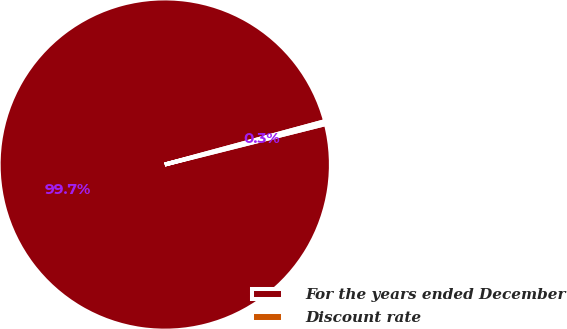<chart> <loc_0><loc_0><loc_500><loc_500><pie_chart><fcel>For the years ended December<fcel>Discount rate<nl><fcel>99.71%<fcel>0.29%<nl></chart> 